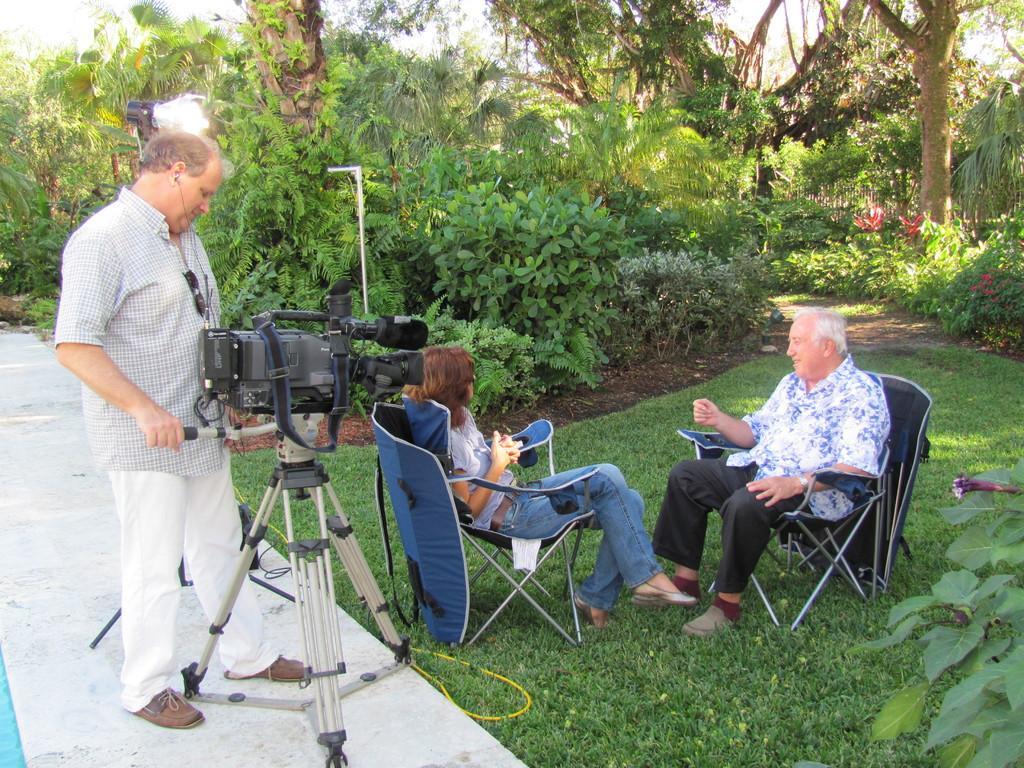Could you give a brief overview of what you see in this image? In this picture we can see two persons sitting on chairs, on the left side there is a man standing and looking at the camera, we can see a tripod here, in the background there are some trees, we can see grass at the bottom, there is a light here. 